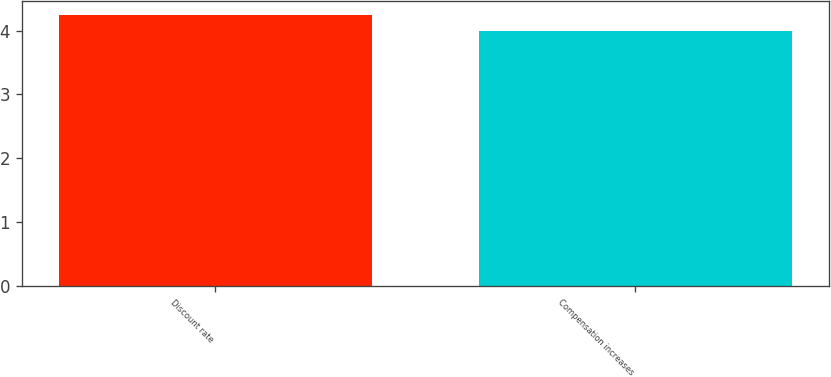Convert chart. <chart><loc_0><loc_0><loc_500><loc_500><bar_chart><fcel>Discount rate<fcel>Compensation increases<nl><fcel>4.25<fcel>4<nl></chart> 